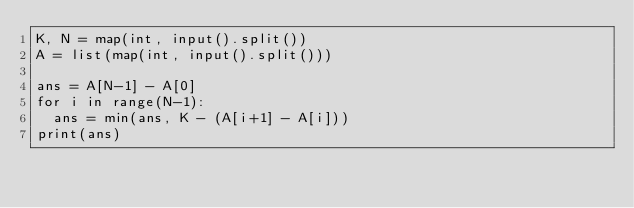<code> <loc_0><loc_0><loc_500><loc_500><_Python_>K, N = map(int, input().split())
A = list(map(int, input().split()))

ans = A[N-1] - A[0]
for i in range(N-1):
  ans = min(ans, K - (A[i+1] - A[i]))
print(ans)</code> 